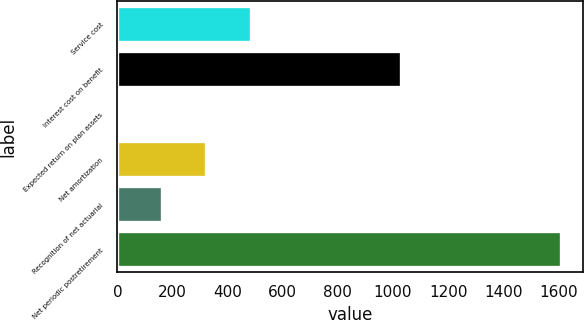Convert chart. <chart><loc_0><loc_0><loc_500><loc_500><bar_chart><fcel>Service cost<fcel>Interest cost on benefit<fcel>Expected return on plan assets<fcel>Net amortization<fcel>Recognition of net actuarial<fcel>Net periodic postretirement<nl><fcel>482.86<fcel>1030<fcel>0.67<fcel>322.13<fcel>161.4<fcel>1608<nl></chart> 